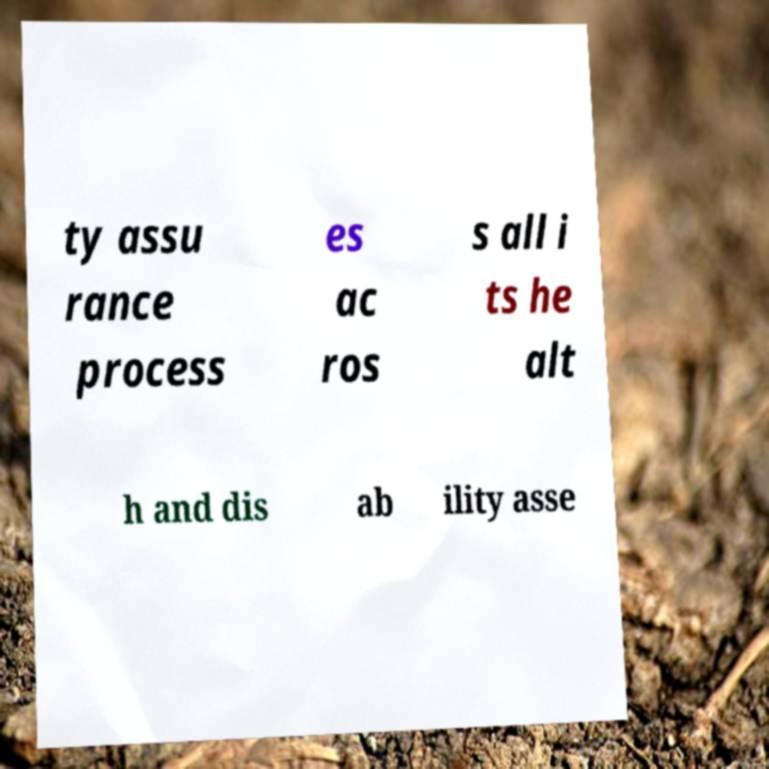Could you assist in decoding the text presented in this image and type it out clearly? ty assu rance process es ac ros s all i ts he alt h and dis ab ility asse 